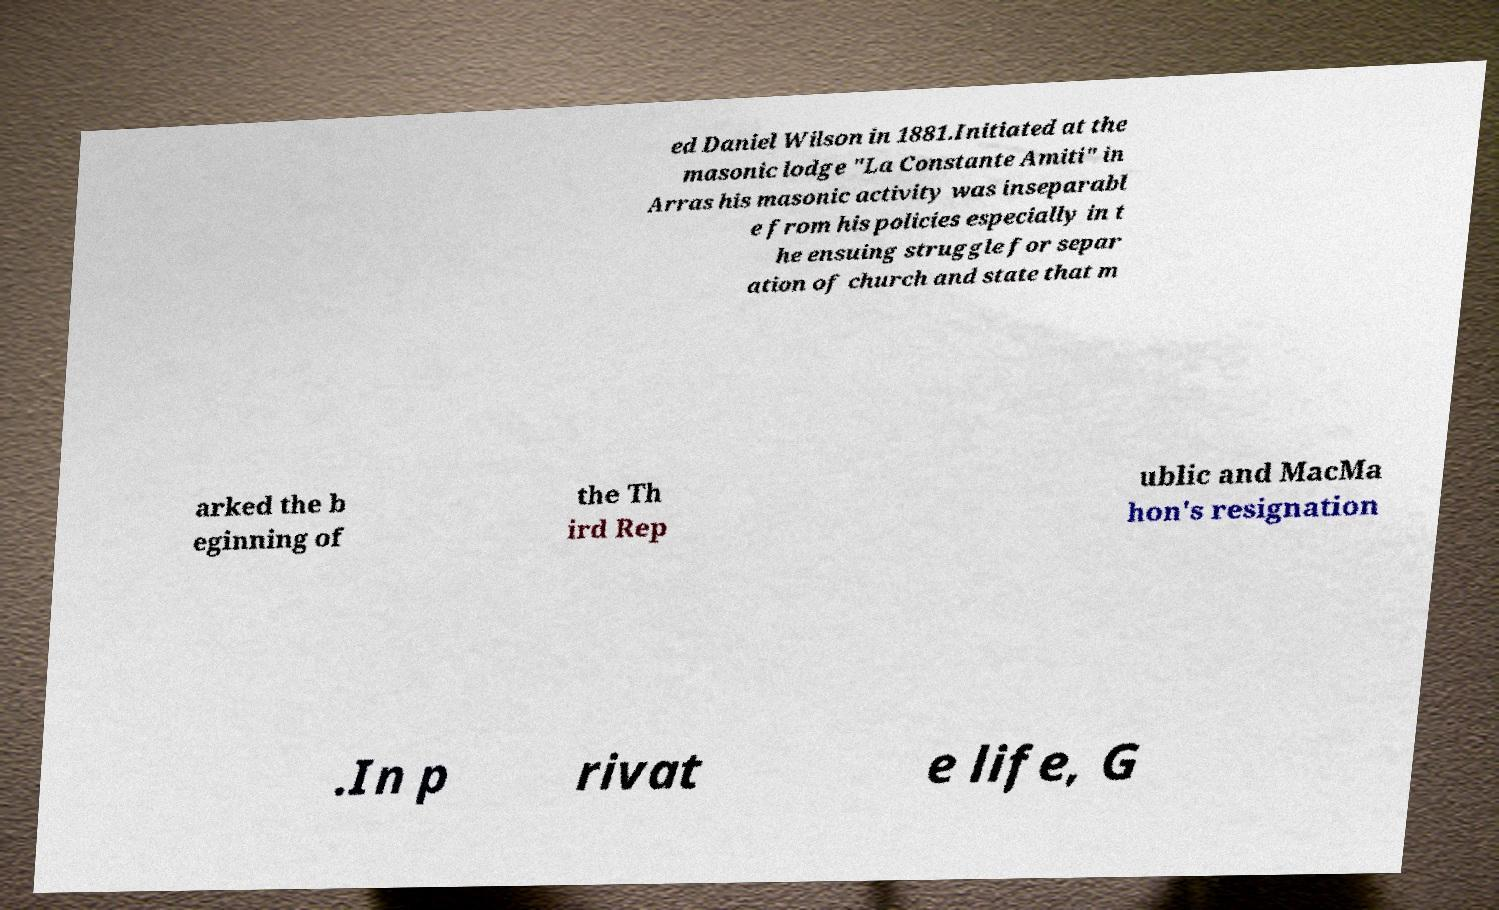I need the written content from this picture converted into text. Can you do that? ed Daniel Wilson in 1881.Initiated at the masonic lodge "La Constante Amiti" in Arras his masonic activity was inseparabl e from his policies especially in t he ensuing struggle for separ ation of church and state that m arked the b eginning of the Th ird Rep ublic and MacMa hon's resignation .In p rivat e life, G 